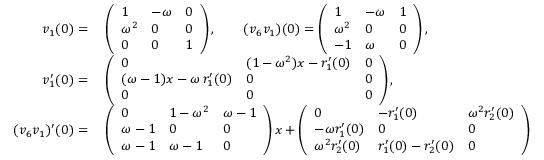Convert formula to latex. <formula><loc_0><loc_0><loc_500><loc_500>\begin{array} { r l } { v _ { 1 } ( 0 ) = } & { \, \left ( \begin{array} { l l l } { 1 } & { - \omega } & { 0 } \\ { \omega ^ { 2 } } & { 0 } & { 0 } \\ { 0 } & { 0 } & { 1 } \end{array} \right ) , \quad ( v _ { 6 } v _ { 1 } ) ( 0 ) = \left ( \begin{array} { l l l } { 1 } & { - \omega } & { 1 } \\ { \omega ^ { 2 } } & { 0 } & { 0 } \\ { - 1 } & { \omega } & { 0 } \end{array} \right ) , } \\ { v _ { 1 } ^ { \prime } ( 0 ) = } & { \, \left ( \begin{array} { l l l } { 0 } & { ( 1 - \omega ^ { 2 } ) x - r _ { 1 } ^ { \prime } ( 0 ) } & { 0 } \\ { ( \omega - 1 ) x - \omega \, r _ { 1 } ^ { \prime } ( 0 ) } & { 0 } & { 0 } \\ { 0 } & { 0 } & { 0 } \end{array} \right ) , } \\ { ( v _ { 6 } v _ { 1 } ) ^ { \prime } ( 0 ) = } & { \, \left ( \begin{array} { l l l } { 0 } & { 1 - \omega ^ { 2 } } & { \omega - 1 } \\ { \omega - 1 } & { 0 } & { 0 } \\ { \omega - 1 } & { \omega - 1 } & { 0 } \end{array} \right ) x + \left ( \begin{array} { l l l } { 0 } & { - r _ { 1 } ^ { \prime } ( 0 ) } & { \omega ^ { 2 } r _ { 2 } ^ { \prime } ( 0 ) } \\ { - \omega r _ { 1 } ^ { \prime } ( 0 ) } & { 0 } & { 0 } \\ { \omega ^ { 2 } r _ { 2 } ^ { \prime } ( 0 ) } & { r _ { 1 } ^ { \prime } ( 0 ) - r _ { 2 } ^ { \prime } ( 0 ) } & { 0 } \end{array} \right ) } \end{array}</formula> 